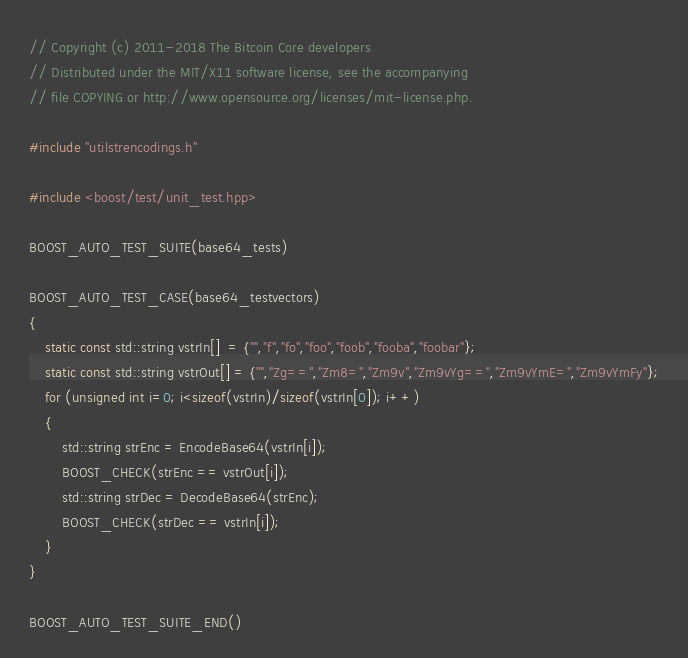Convert code to text. <code><loc_0><loc_0><loc_500><loc_500><_C++_>// Copyright (c) 2011-2018 The Bitcoin Core developers
// Distributed under the MIT/X11 software license, see the accompanying
// file COPYING or http://www.opensource.org/licenses/mit-license.php.

#include "utilstrencodings.h"

#include <boost/test/unit_test.hpp>

BOOST_AUTO_TEST_SUITE(base64_tests)

BOOST_AUTO_TEST_CASE(base64_testvectors)
{
    static const std::string vstrIn[]  = {"","f","fo","foo","foob","fooba","foobar"};
    static const std::string vstrOut[] = {"","Zg==","Zm8=","Zm9v","Zm9vYg==","Zm9vYmE=","Zm9vYmFy"};
    for (unsigned int i=0; i<sizeof(vstrIn)/sizeof(vstrIn[0]); i++)
    {
        std::string strEnc = EncodeBase64(vstrIn[i]);
        BOOST_CHECK(strEnc == vstrOut[i]);
        std::string strDec = DecodeBase64(strEnc);
        BOOST_CHECK(strDec == vstrIn[i]);
    }
}

BOOST_AUTO_TEST_SUITE_END()
</code> 